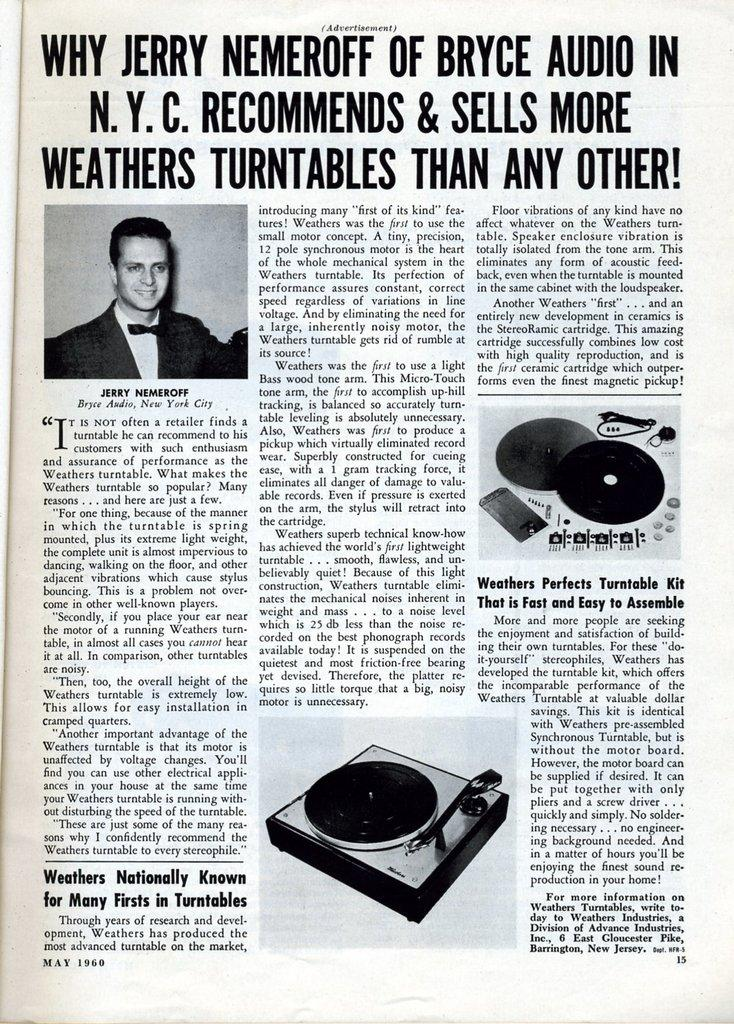What is the main object in the image? There is a newspaper in the image. What can be seen on the newspaper? There is writing on the newspaper. Can you describe the person visible in the image? There is a person visible in the image. What else is present on the newspaper? There are objects on the newspaper. How many legs does the watch have in the image? There is no watch present in the image, so it is not possible to determine the number of legs it might have. 